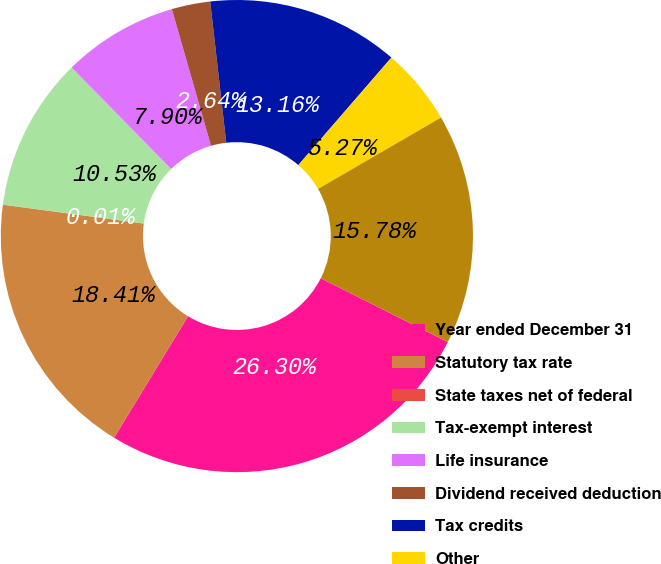Convert chart to OTSL. <chart><loc_0><loc_0><loc_500><loc_500><pie_chart><fcel>Year ended December 31<fcel>Statutory tax rate<fcel>State taxes net of federal<fcel>Tax-exempt interest<fcel>Life insurance<fcel>Dividend received deduction<fcel>Tax credits<fcel>Other<fcel>Effective tax rate<nl><fcel>26.3%<fcel>18.41%<fcel>0.01%<fcel>10.53%<fcel>7.9%<fcel>2.64%<fcel>13.16%<fcel>5.27%<fcel>15.78%<nl></chart> 